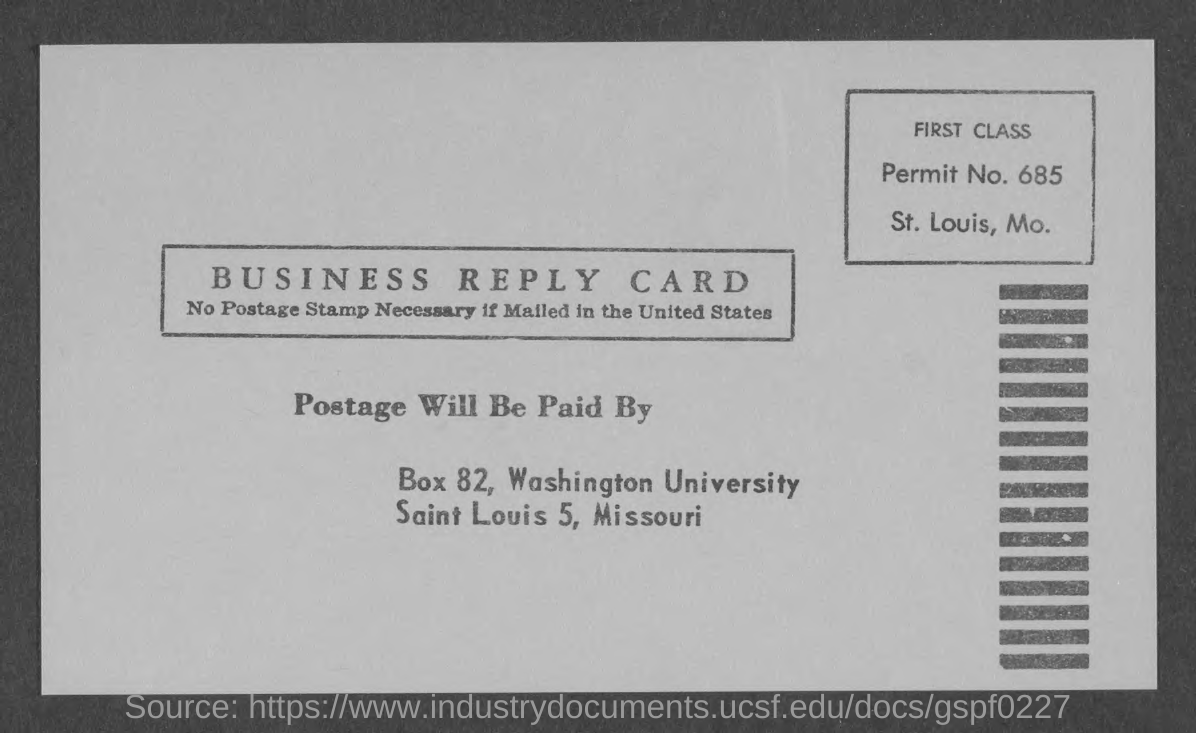Mention a couple of crucial points in this snapshot. The permit number is 685. 